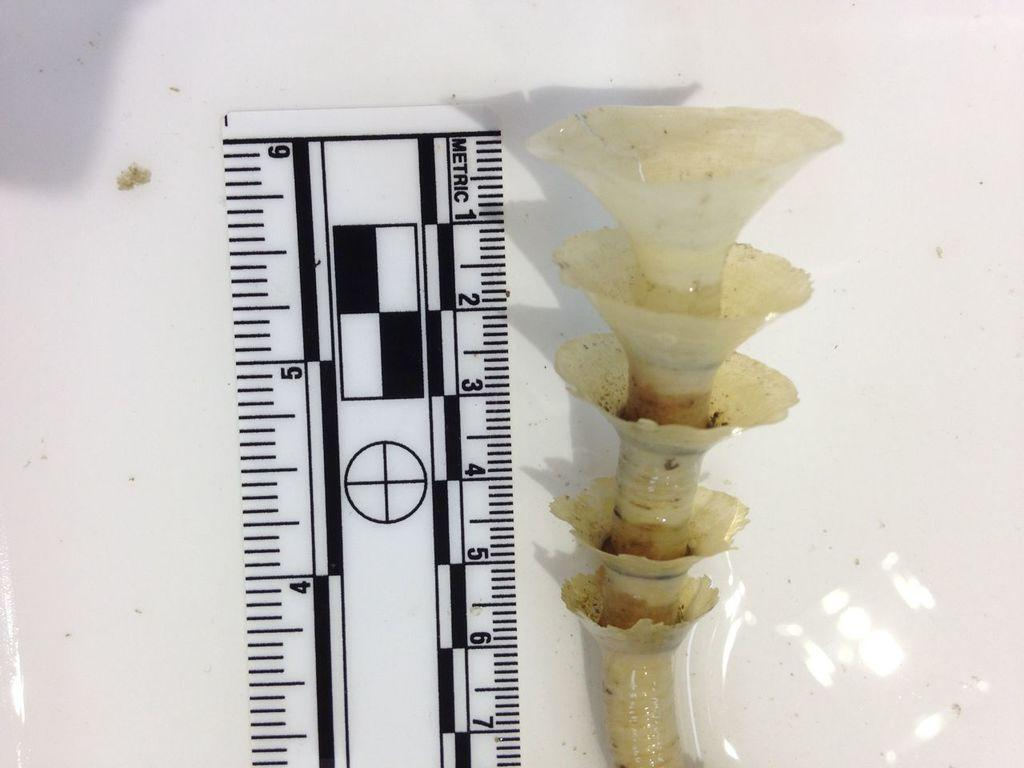<image>
Describe the image concisely. A ruler is measuring something that is 6 inches tall. 